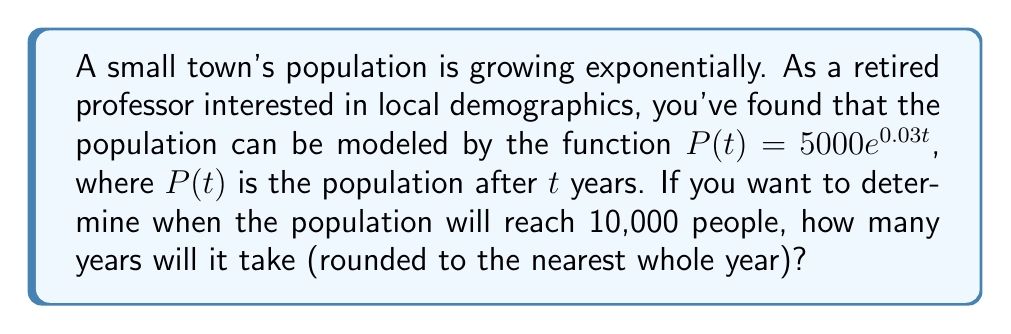Solve this math problem. Let's approach this step-by-step:

1) We start with the given exponential function:
   $P(t) = 5000e^{0.03t}$

2) We want to find $t$ when $P(t) = 10000$. So, let's set up the equation:
   $10000 = 5000e^{0.03t}$

3) Divide both sides by 5000:
   $2 = e^{0.03t}$

4) Take the natural logarithm of both sides:
   $\ln(2) = \ln(e^{0.03t})$

5) Using the property of logarithms, $\ln(e^x) = x$:
   $\ln(2) = 0.03t$

6) Solve for $t$:
   $t = \frac{\ln(2)}{0.03}$

7) Calculate the value:
   $t \approx 23.1049$ years

8) Rounding to the nearest whole year:
   $t \approx 23$ years

Therefore, it will take approximately 23 years for the population to reach 10,000 people.
Answer: 23 years 